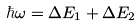Convert formula to latex. <formula><loc_0><loc_0><loc_500><loc_500>\hbar { \omega } = \Delta E _ { 1 } + \Delta E _ { 2 }</formula> 